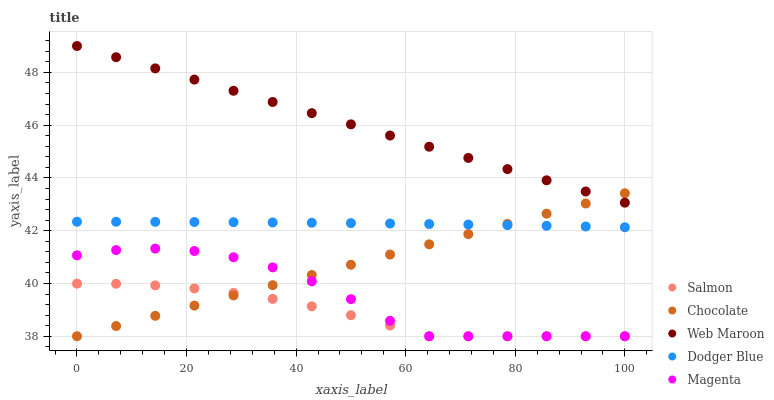Does Salmon have the minimum area under the curve?
Answer yes or no. Yes. Does Web Maroon have the maximum area under the curve?
Answer yes or no. Yes. Does Magenta have the minimum area under the curve?
Answer yes or no. No. Does Magenta have the maximum area under the curve?
Answer yes or no. No. Is Web Maroon the smoothest?
Answer yes or no. Yes. Is Magenta the roughest?
Answer yes or no. Yes. Is Salmon the smoothest?
Answer yes or no. No. Is Salmon the roughest?
Answer yes or no. No. Does Magenta have the lowest value?
Answer yes or no. Yes. Does Dodger Blue have the lowest value?
Answer yes or no. No. Does Web Maroon have the highest value?
Answer yes or no. Yes. Does Magenta have the highest value?
Answer yes or no. No. Is Magenta less than Dodger Blue?
Answer yes or no. Yes. Is Web Maroon greater than Dodger Blue?
Answer yes or no. Yes. Does Magenta intersect Salmon?
Answer yes or no. Yes. Is Magenta less than Salmon?
Answer yes or no. No. Is Magenta greater than Salmon?
Answer yes or no. No. Does Magenta intersect Dodger Blue?
Answer yes or no. No. 